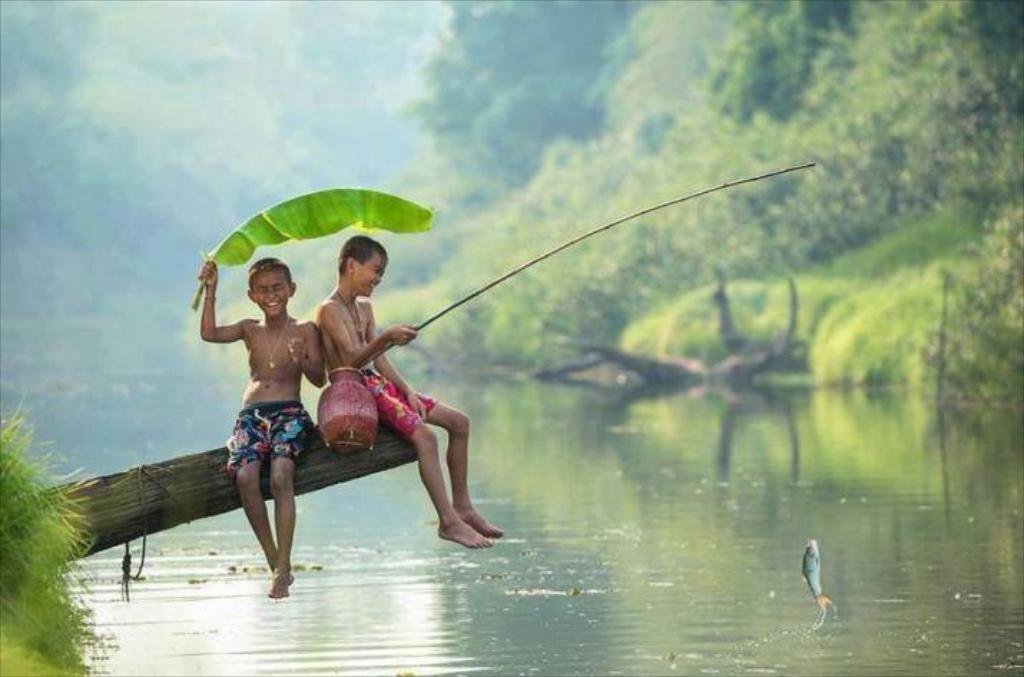Could you give a brief overview of what you see in this image? In this picture there are two boys wearing colorful shorts setting on the tree trunk and catching the fishes with the rod. Behind there is a blur background with some green trees. 